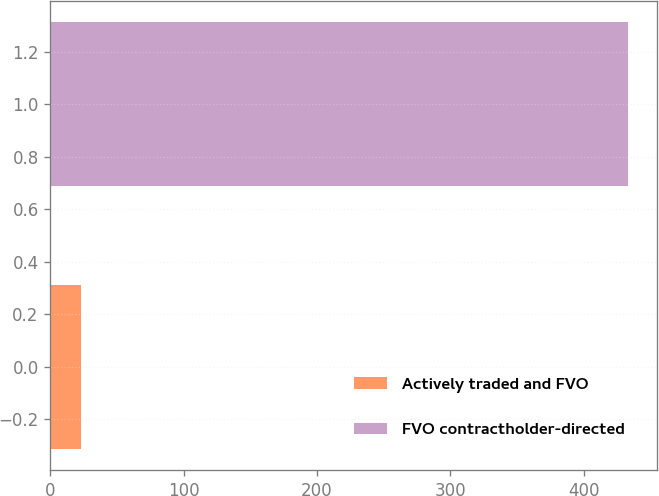Convert chart to OTSL. <chart><loc_0><loc_0><loc_500><loc_500><bar_chart><fcel>Actively traded and FVO<fcel>FVO contractholder-directed<nl><fcel>23<fcel>433<nl></chart> 